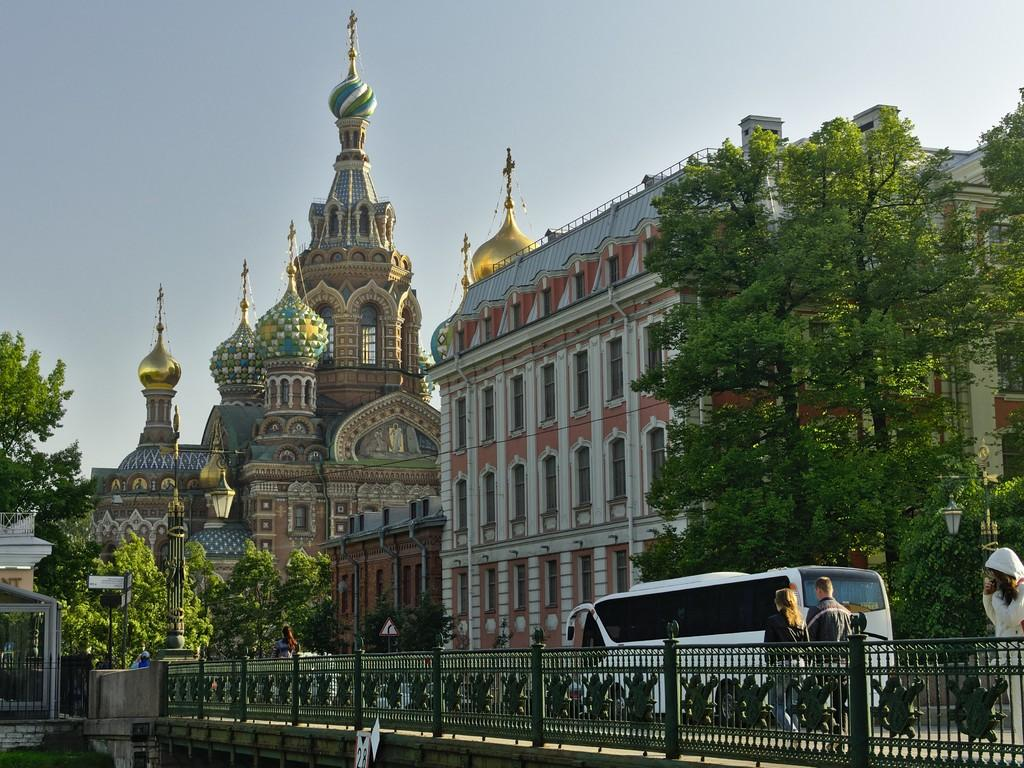What type of barrier can be seen in the image? There is a fence in the image. Who or what is present in the image? There are people and a vehicle on the road in the image. What structures are visible in the image? There are buildings in the image. What type of vegetation is present in the image? There are trees in the image. What type of informational sign is present in the image? There is a sign board in the image. What type of illumination is present in the image? There are lights in the image. What other objects can be seen in the image? There are some objects in the image. What can be seen in the background of the image? The sky is visible in the background of the image. What type of bulb is being used to read a book in the image? There is no indication in the image that anyone is reading a book or using a bulb for that purpose. What type of insurance policy is being discussed by the people in the image? There is no indication in the image that the people are discussing insurance or any related topic. 